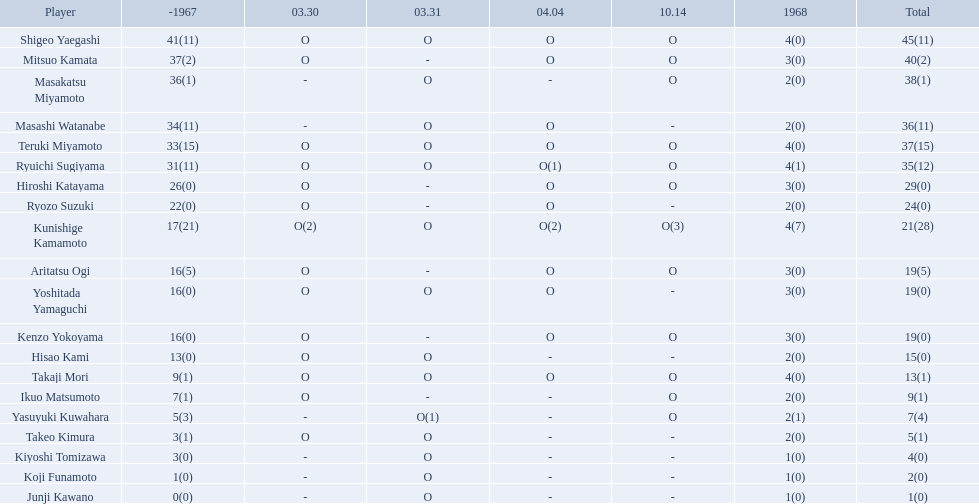Who were the players in the 1968 japanese football? Shigeo Yaegashi, Mitsuo Kamata, Masakatsu Miyamoto, Masashi Watanabe, Teruki Miyamoto, Ryuichi Sugiyama, Hiroshi Katayama, Ryozo Suzuki, Kunishige Kamamoto, Aritatsu Ogi, Yoshitada Yamaguchi, Kenzo Yokoyama, Hisao Kami, Takaji Mori, Ikuo Matsumoto, Yasuyuki Kuwahara, Takeo Kimura, Kiyoshi Tomizawa, Koji Funamoto, Junji Kawano. How many points total did takaji mori have? 13(1). How many points total did junju kawano? 1(0). Who had more points? Takaji Mori. Who were the participants in the 1968 japanese soccer? Shigeo Yaegashi, Mitsuo Kamata, Masakatsu Miyamoto, Masashi Watanabe, Teruki Miyamoto, Ryuichi Sugiyama, Hiroshi Katayama, Ryozo Suzuki, Kunishige Kamamoto, Aritatsu Ogi, Yoshitada Yamaguchi, Kenzo Yokoyama, Hisao Kami, Takaji Mori, Ikuo Matsumoto, Yasuyuki Kuwahara, Takeo Kimura, Kiyoshi Tomizawa, Koji Funamoto, Junji Kawano. What was takaji mori's total score? 13(1). What was junju kawano's total score? 1(0). Who scored higher? Takaji Mori. Who are all the competitors? Shigeo Yaegashi, Mitsuo Kamata, Masakatsu Miyamoto, Masashi Watanabe, Teruki Miyamoto, Ryuichi Sugiyama, Hiroshi Katayama, Ryozo Suzuki, Kunishige Kamamoto, Aritatsu Ogi, Yoshitada Yamaguchi, Kenzo Yokoyama, Hisao Kami, Takaji Mori, Ikuo Matsumoto, Yasuyuki Kuwahara, Takeo Kimura, Kiyoshi Tomizawa, Koji Funamoto, Junji Kawano. How many points were they given? 45(11), 40(2), 38(1), 36(11), 37(15), 35(12), 29(0), 24(0), 21(28), 19(5), 19(0), 19(0), 15(0), 13(1), 9(1), 7(4), 5(1), 4(0), 2(0), 1(0). What about only takaji mori and junji kawano? 13(1), 1(0). Among the two, who had more points? Takaji Mori. Who took part in the 1968 japanese football? Shigeo Yaegashi, Mitsuo Kamata, Masakatsu Miyamoto, Masashi Watanabe, Teruki Miyamoto, Ryuichi Sugiyama, Hiroshi Katayama, Ryozo Suzuki, Kunishige Kamamoto, Aritatsu Ogi, Yoshitada Yamaguchi, Kenzo Yokoyama, Hisao Kami, Takaji Mori, Ikuo Matsumoto, Yasuyuki Kuwahara, Takeo Kimura, Kiyoshi Tomizawa, Koji Funamoto, Junji Kawano. How many points did takaji mori accumulate? 13(1). How many points did junju kawano accumulate? 1(0). Who had a greater score? Takaji Mori. Who were the competitors in the 1968 japanese football? Shigeo Yaegashi, Mitsuo Kamata, Masakatsu Miyamoto, Masashi Watanabe, Teruki Miyamoto, Ryuichi Sugiyama, Hiroshi Katayama, Ryozo Suzuki, Kunishige Kamamoto, Aritatsu Ogi, Yoshitada Yamaguchi, Kenzo Yokoyama, Hisao Kami, Takaji Mori, Ikuo Matsumoto, Yasuyuki Kuwahara, Takeo Kimura, Kiyoshi Tomizawa, Koji Funamoto, Junji Kawano. What was the overall score for takaji mori? 13(1). What was the overall score for junju kawano? 1(0). Who had a higher score? Takaji Mori. In the 1968 japanese football, who were the players involved? Shigeo Yaegashi, Mitsuo Kamata, Masakatsu Miyamoto, Masashi Watanabe, Teruki Miyamoto, Ryuichi Sugiyama, Hiroshi Katayama, Ryozo Suzuki, Kunishige Kamamoto, Aritatsu Ogi, Yoshitada Yamaguchi, Kenzo Yokoyama, Hisao Kami, Takaji Mori, Ikuo Matsumoto, Yasuyuki Kuwahara, Takeo Kimura, Kiyoshi Tomizawa, Koji Funamoto, Junji Kawano. What was the overall score for takaji mori? 13(1). How many points did junju kawano accumulate? 1(0). Which player had more points? Takaji Mori. 